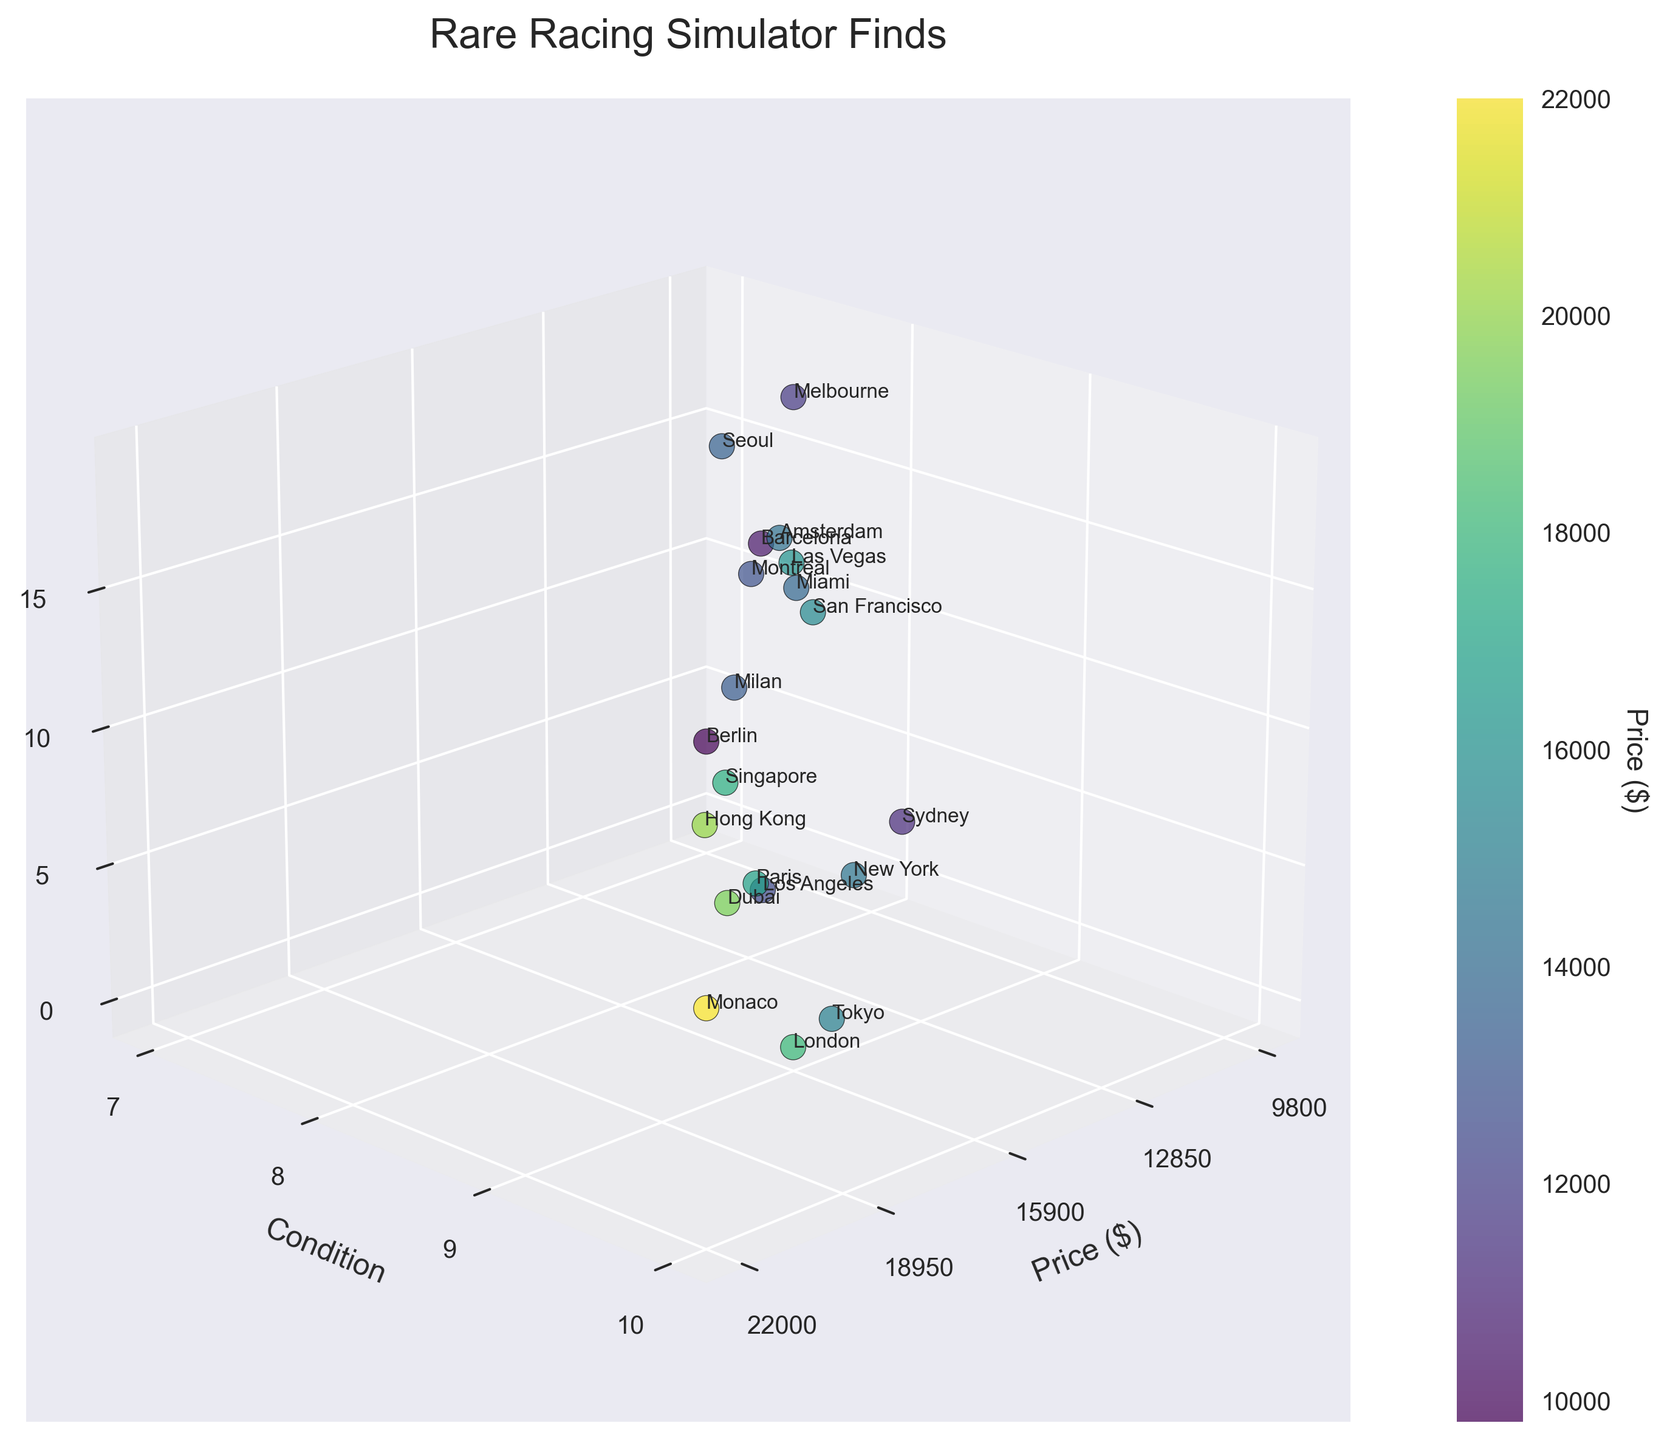What is the title of the plot? The title of the plot typically appears at the top of the plot area. It describes the main insight or focus of the plot.
Answer: Rare Racing Simulator Finds Which city has the highest price for a rare racing simulator? By observing the plot's highest point on the x-axis labeled "Price ($)," we identify that Monaco has the highest price.
Answer: Monaco How many cities have a condition rating of 9? Look at the y-axis for a condition of 9, and count the data points that align with this value.
Answer: 5 Which two cities have the closest price points but different condition ratings? Identify cities with similar x-axis (price) values and compare their y-axis (condition) values to find differences. Two close values around the same (for example, Tokyo and New York) need further scrutiny.
Answer: Tokyo and New York Are there any cities with a condition rating below 8? By checking the y-axis, observe whether any data points are below the marking of 8.
Answer: Yes Which city is represented by the highest z-axis value? The z-axis labeled as "Location Index" represents different locations. The highest value on this axis correlates to the last city on the list, Melbourne.
Answer: Melbourne What is the average price of racing simulators with a condition rating of 9.5? Locate data points with a y-axis value of 9.5 and calculate the average of their x-axis (price) values. The cities are London, Dubai, and Hong Kong. (18000 + 19500 + 20000) / 3 = 19166.67
Answer: 19166.67 Which city has the lowest condition rating paired with its price? Locate the smallest y-axis value and check its corresponding x-axis value. Berlin has a condition rating of 7.
Answer: Berlin How does the price of Singapore's racing simulator compare to that of Paris? Locate both cities on the x-axis and compare their values directly. Singapore has a price of 17500 and Paris has 16800.
Answer: Singapore > Paris Do any two cities have the same price but different condition ratings? Check for any x-axis values that repeat and compare their corresponding y-axis values. There are no exact repeats for price with different conditions here.
Answer: No 